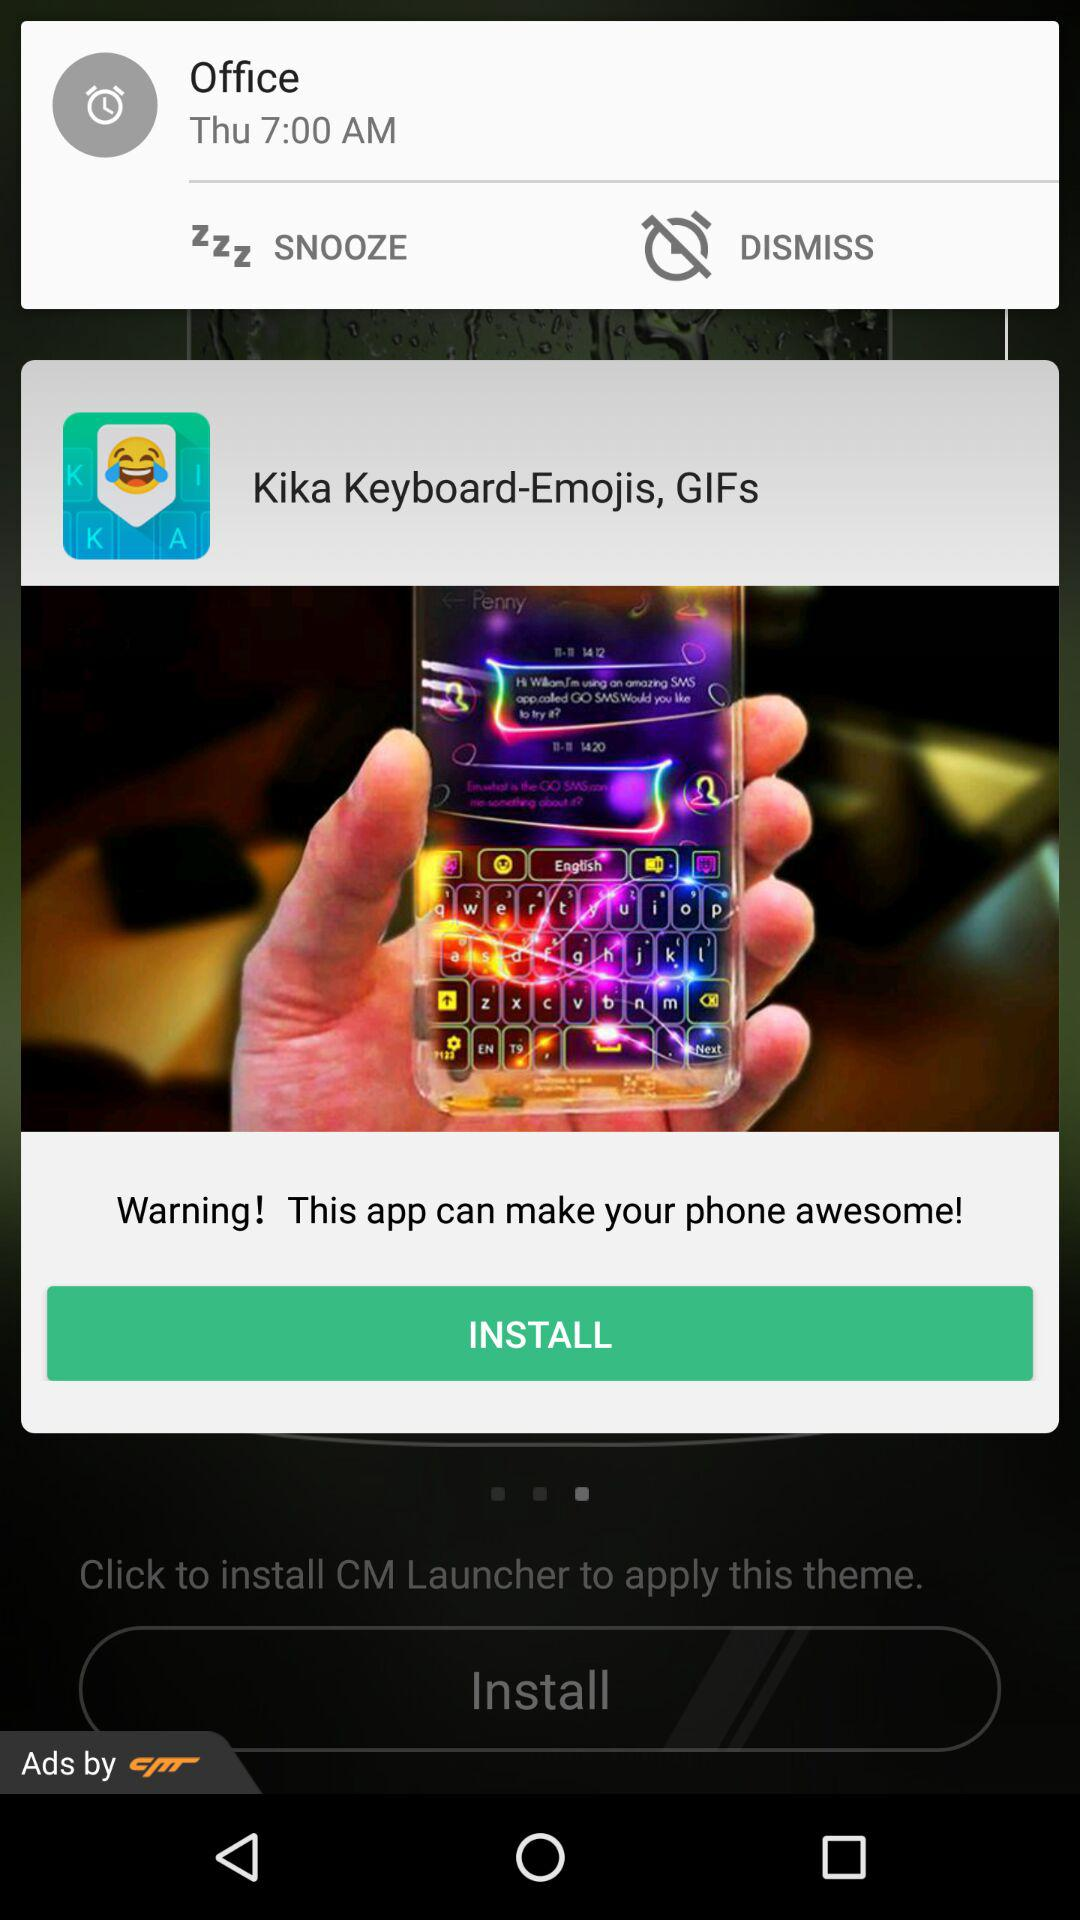What is the alarm time on Thursday? The alarm time on Thursday is 7:00 AM. 